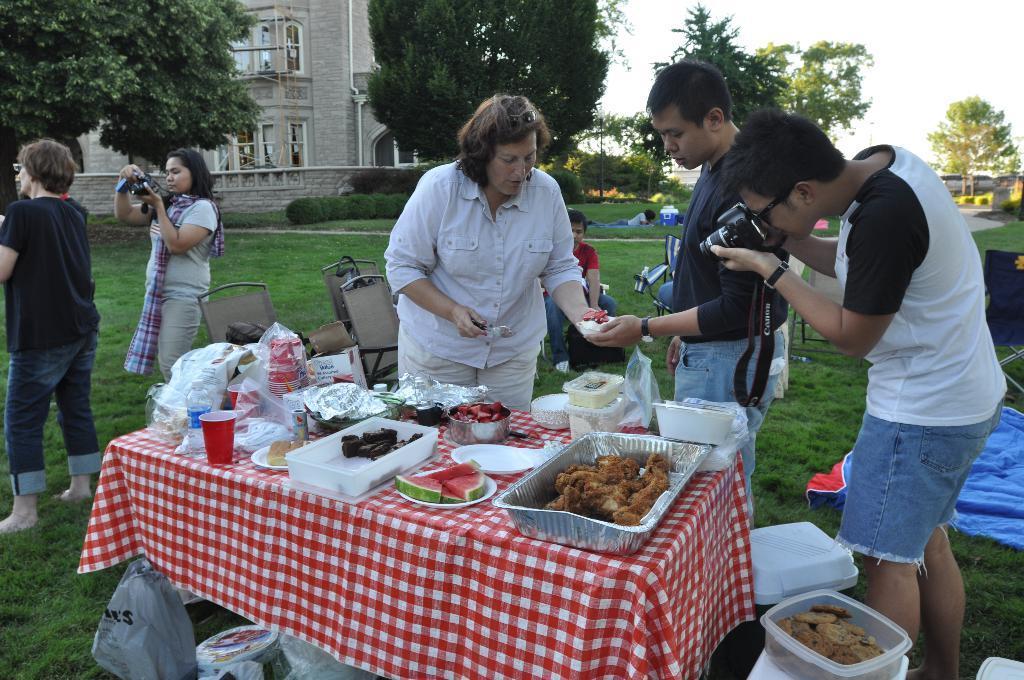How would you summarize this image in a sentence or two? In this picture we can see a group of people standing on the grass and a man sitting on a chair, cameras, table with bowls, plates, tin, plastic covers, bottle, glass and food items on it and in the background we can see a building with windows, trees, sky. 